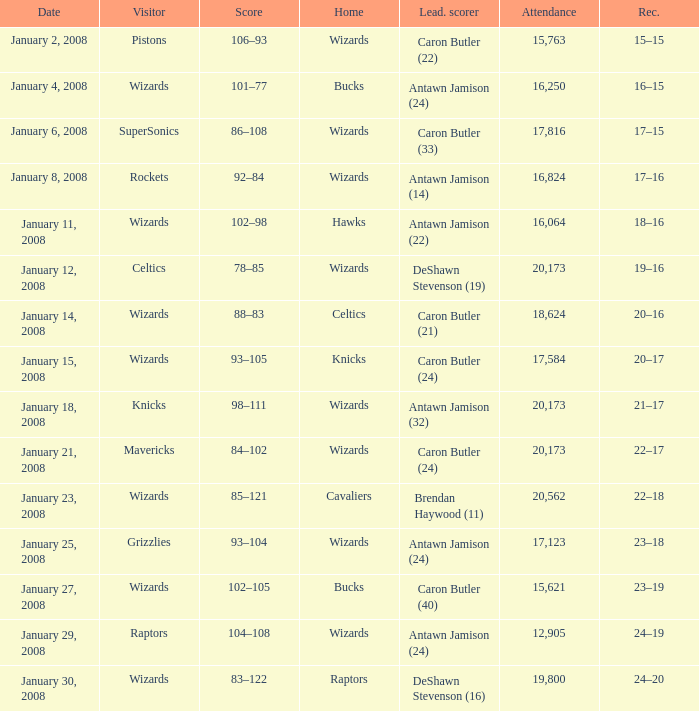Could you help me parse every detail presented in this table? {'header': ['Date', 'Visitor', 'Score', 'Home', 'Lead. scorer', 'Attendance', 'Rec.'], 'rows': [['January 2, 2008', 'Pistons', '106–93', 'Wizards', 'Caron Butler (22)', '15,763', '15–15'], ['January 4, 2008', 'Wizards', '101–77', 'Bucks', 'Antawn Jamison (24)', '16,250', '16–15'], ['January 6, 2008', 'SuperSonics', '86–108', 'Wizards', 'Caron Butler (33)', '17,816', '17–15'], ['January 8, 2008', 'Rockets', '92–84', 'Wizards', 'Antawn Jamison (14)', '16,824', '17–16'], ['January 11, 2008', 'Wizards', '102–98', 'Hawks', 'Antawn Jamison (22)', '16,064', '18–16'], ['January 12, 2008', 'Celtics', '78–85', 'Wizards', 'DeShawn Stevenson (19)', '20,173', '19–16'], ['January 14, 2008', 'Wizards', '88–83', 'Celtics', 'Caron Butler (21)', '18,624', '20–16'], ['January 15, 2008', 'Wizards', '93–105', 'Knicks', 'Caron Butler (24)', '17,584', '20–17'], ['January 18, 2008', 'Knicks', '98–111', 'Wizards', 'Antawn Jamison (32)', '20,173', '21–17'], ['January 21, 2008', 'Mavericks', '84–102', 'Wizards', 'Caron Butler (24)', '20,173', '22–17'], ['January 23, 2008', 'Wizards', '85–121', 'Cavaliers', 'Brendan Haywood (11)', '20,562', '22–18'], ['January 25, 2008', 'Grizzlies', '93–104', 'Wizards', 'Antawn Jamison (24)', '17,123', '23–18'], ['January 27, 2008', 'Wizards', '102–105', 'Bucks', 'Caron Butler (40)', '15,621', '23–19'], ['January 29, 2008', 'Raptors', '104–108', 'Wizards', 'Antawn Jamison (24)', '12,905', '24–19'], ['January 30, 2008', 'Wizards', '83–122', 'Raptors', 'DeShawn Stevenson (16)', '19,800', '24–20']]} How many people were in attendance on January 4, 2008? 16250.0. 